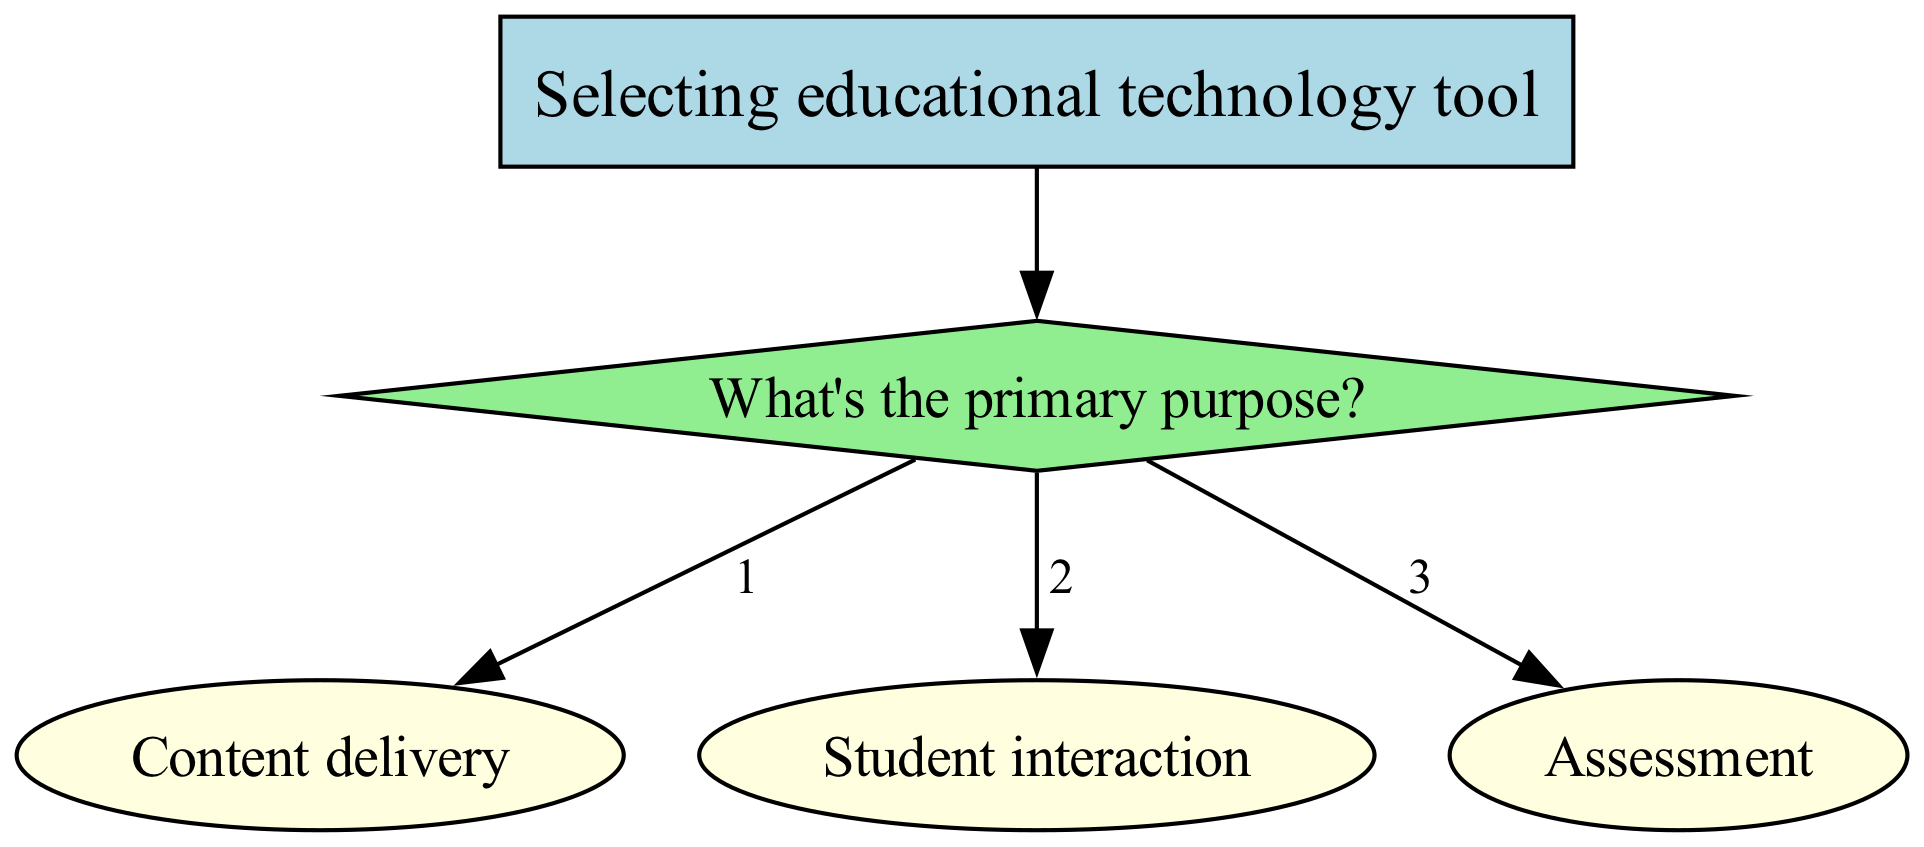What's the primary purpose of the decision tree? The root of the decision tree clearly indicates that it is focused on "Selecting educational technology tool," which leads to the first level of questions about the primary purpose. This is the first question that guides the flow of the diagram.
Answer: Selecting educational technology tool How many options are there under "Student interaction"? Under the primary purpose of "Student interaction," there are three options presented: Discussions, Quizzes, and Collaborative projects. Therefore, by counting these options, we conclude there are three.
Answer: Three What is the tool associated with "Content delivery" for "Video"? In the decision tree, under the node for "Content delivery," when the content type is specified as "Video," the associated tool is clearly indicated as "YouTube."
Answer: YouTube Which assessment type has "Google Forms" as a tool? The decision tree features an assessment category, where "Multiple choice" is mentioned as the type that is paired with "Google Forms" as the corresponding tool. Thus, identifying the relationship leads us to this answer.
Answer: Multiple choice If the purpose is "Student interaction" and the interaction is "Collaborative projects," what is the tool selected? Following the decision-making process in the diagram, if the primary purpose selected is "Student interaction" and the type of interaction chosen is "Collaborative projects," the tool indicated is "Microsoft Teams." This is derived directly from the flow of options under the "Student interaction" node.
Answer: Microsoft Teams How many primary purposes are there in the decision tree? The root node branches out into three distinct primary purposes: Content delivery, Student interaction, and Assessment. Counting these branches yields a total of three primary purposes.
Answer: Three What tool corresponds to "Open-ended" assessment type? The node for "Assessment" indicates that the tool related to the assessment type "Open-ended" is "Flipgrid." This information is explicitly detailed in the diagram and is straightforward to derive.
Answer: Flipgrid What is the relationship between "Quizzes" and "Kahoot"? In the decision tree, "Quizzes" falls under the node for "Student interaction," and "Kahoot" is the corresponding tool connected to this interaction type. Thus, the relationship is that "Kahoot" is the tool for "Quizzes."
Answer: Kahoot is the tool for Quizzes 